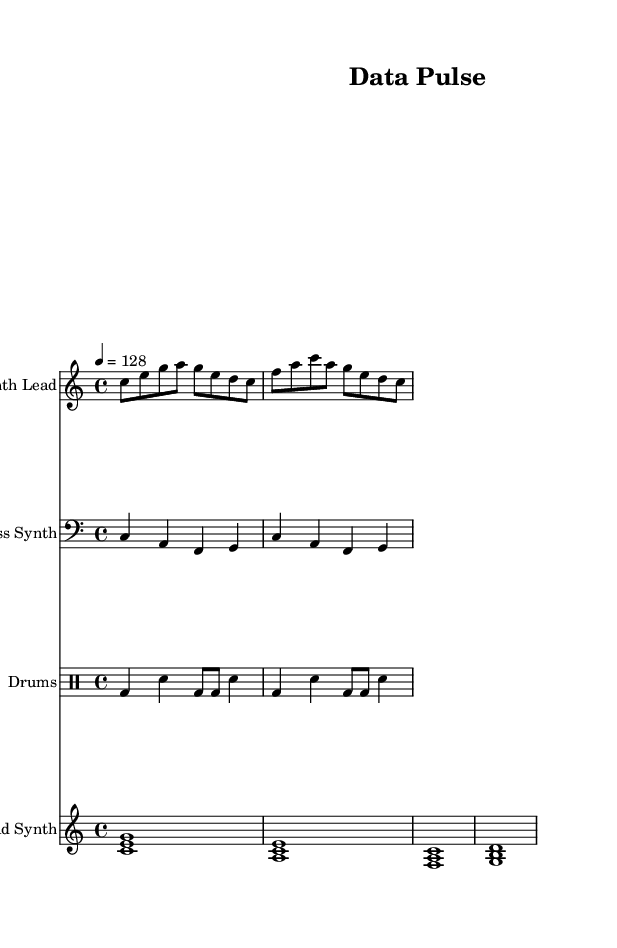what is the key signature of this music? The key signature is C major, which has no sharps or flats.
Answer: C major what is the time signature of this music? The time signature is identified at the beginning of the score, and it is 4/4, indicating four beats per measure.
Answer: 4/4 what is the tempo marking of the piece? The tempo marking is found in the global settings, indicating the speed of the piece, specifically mentioned as quarter note equals 128 beats per minute.
Answer: 128 how many measures does the synth lead part contain? The synth lead section comprises a total of 8 measures, which can be counted from the beginning to the end of the notated music.
Answer: 8 which instruments are used in this score? The instruments listed include a synth lead, a bass synth, drums, and a pad synth, each denoted by their specific names in the score.
Answer: Synth Lead, Bass Synth, Drums, Pad Synth what is the rhythmic pattern of the drum part? Analyzing the drum part, the pattern consists of kicks on beats 1 and 3, with snares on beats 2 and 4, plus additional rhythmic variations using eighth notes.
Answer: Kick on beats 1 and 3; snare on beats 2 and 4 which synth plays the lowest notes? The bass synth part is characterized by lower pitch notes particularly written in the bass clef, making it the instrumental part that plays the lowest notes in this piece.
Answer: Bass Synth 